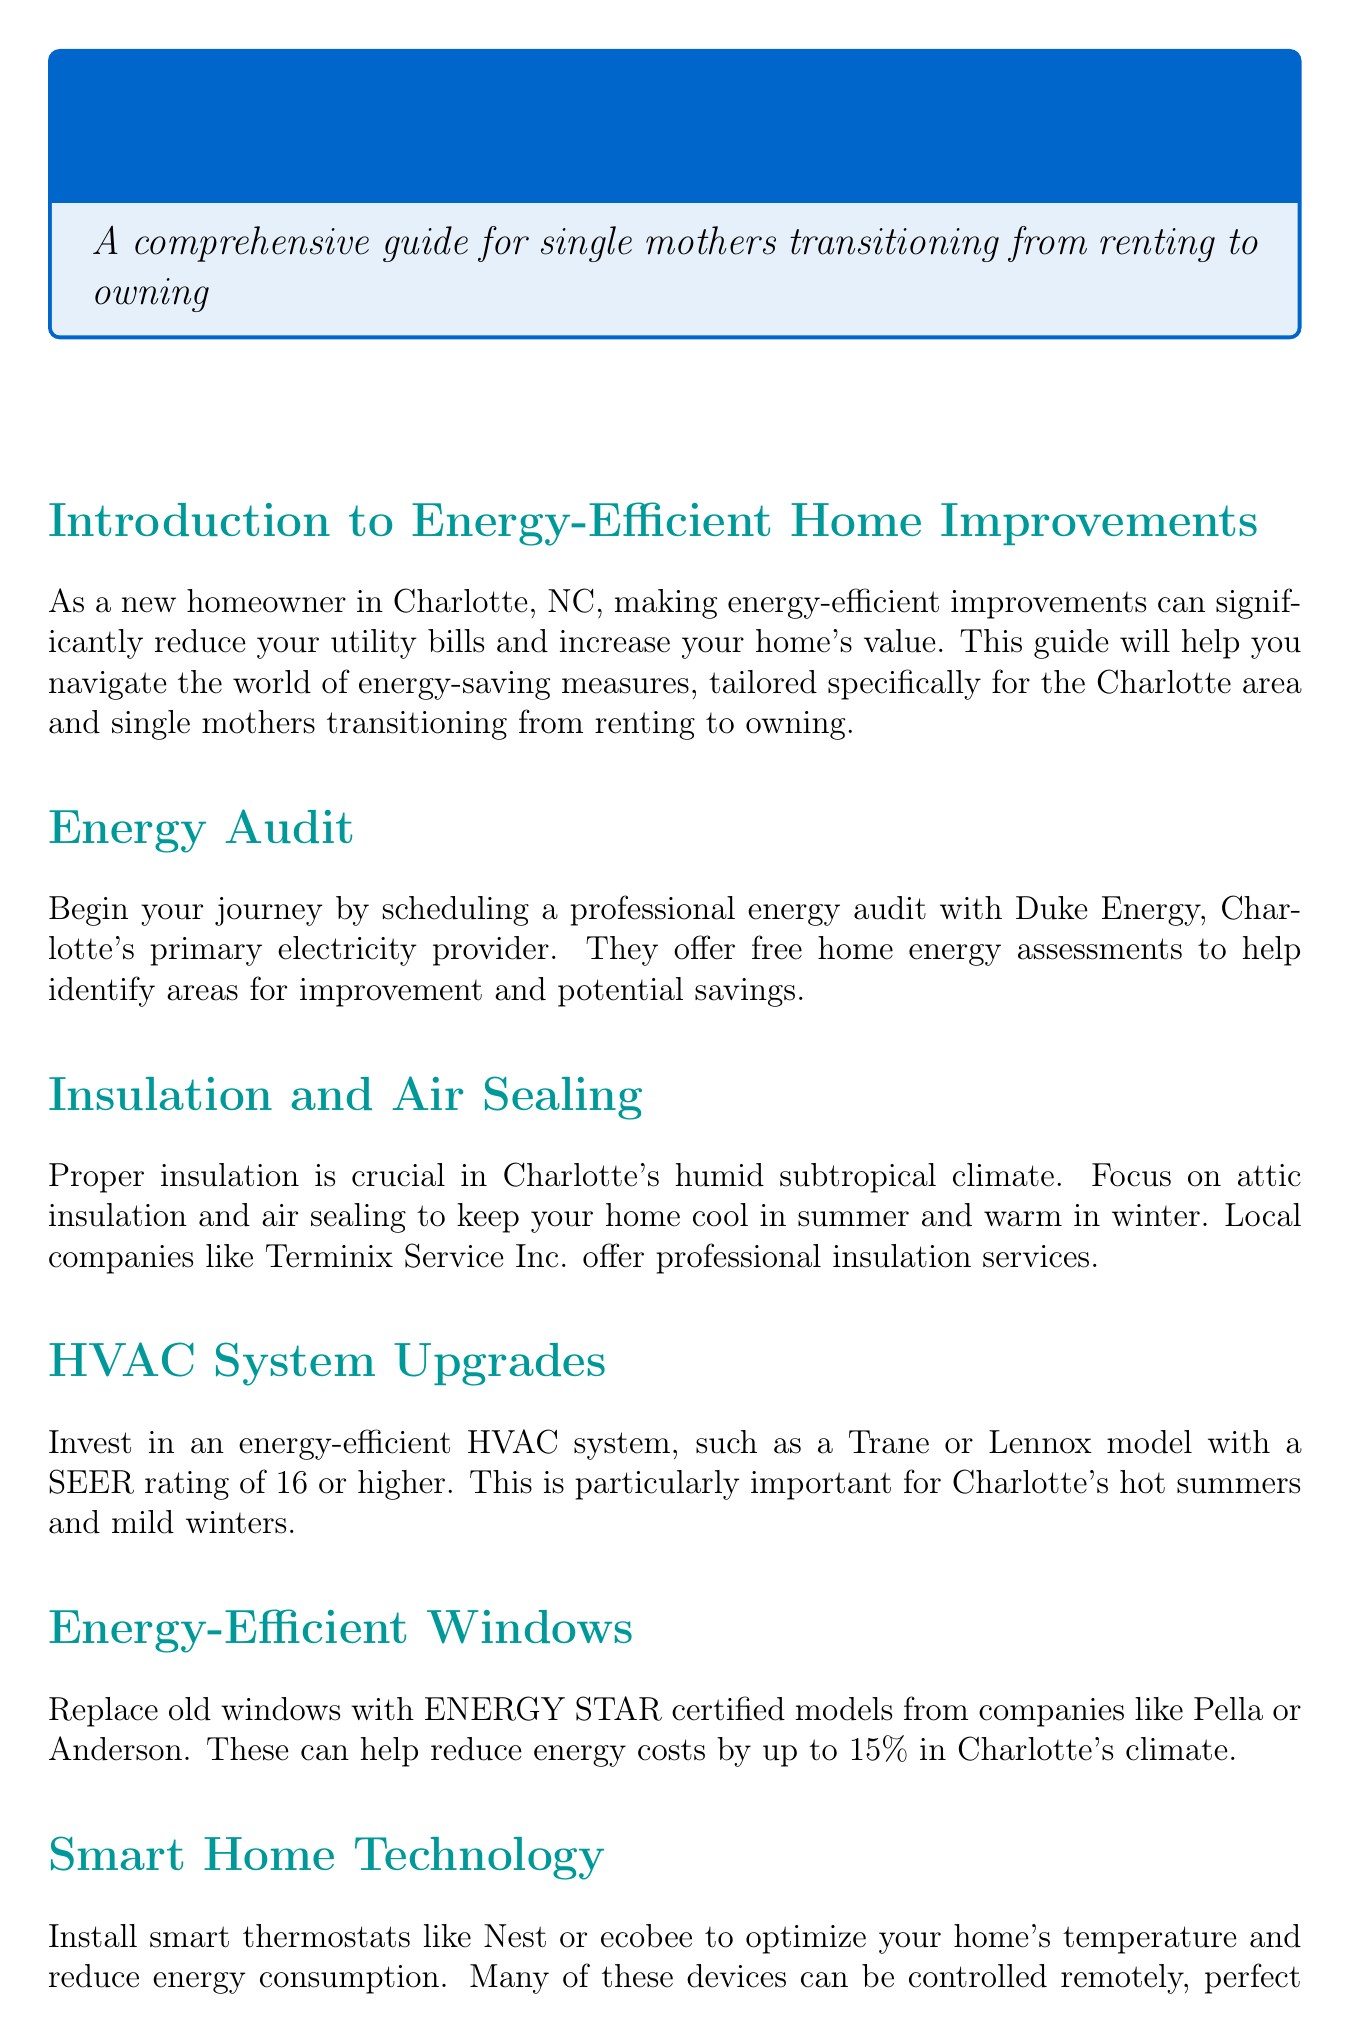What is the primary electricity provider in Charlotte? Duke Energy is mentioned as the primary electricity provider for energy audits in Charlotte.
Answer: Duke Energy What type of HVAC system is recommended? The document specifies investing in an energy-efficient HVAC system with a SEER rating of 16 or higher.
Answer: SEER rating of 16 or higher What are LED bulbs? LED bulbs are mentioned as alternatives to replace all light bulbs for energy savings in the document.
Answer: Alternatives What kind of fixtures should be used for water conservation? The document recommends low-flow fixtures and ENERGY STAR certified appliances.
Answer: Low-flow fixtures Which local company offers consultations for solar panel installation? Renu Energy Solutions is mentioned as a local company that provides consultations and installation services for solar panels.
Answer: Renu Energy Solutions What is the title of the guide? The title of the guide is mentioned at the beginning of the document.
Answer: Energy-Efficient Home Guide for New Charlotte Homeowners What is the purpose of the Smart $aver program? The Smart $aver program is described as offering rebates for HVAC upgrades, insulation improvements, and more.
Answer: Rebates Which federal tax credit is available for energy-efficient home improvements? The document lists the Residential Renewable Energy Tax Credit as an available federal tax credit.
Answer: Residential Renewable Energy Tax Credit What should a new homeowner do first? The document suggests scheduling a professional energy audit as the first step for a new homeowner.
Answer: Schedule an energy audit 